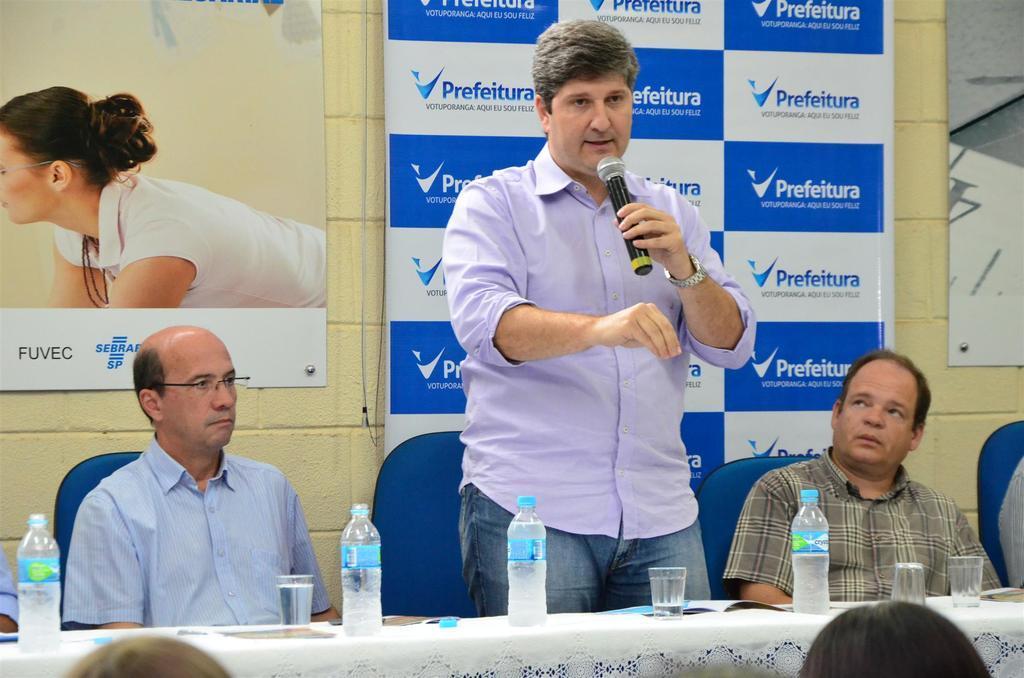Could you give a brief overview of what you see in this image? In this picture we can see two men are sitting on chairs and a man is standing and holding a microphone, we can see a table in the front, there is a cloth, water bottles, glasses present on the table, in the background there is a wall, on the left side we can see a poster, there is a hoarding in the middle, we can see logos and some text on the hoarding. 